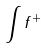Convert formula to latex. <formula><loc_0><loc_0><loc_500><loc_500>\int f ^ { + }</formula> 